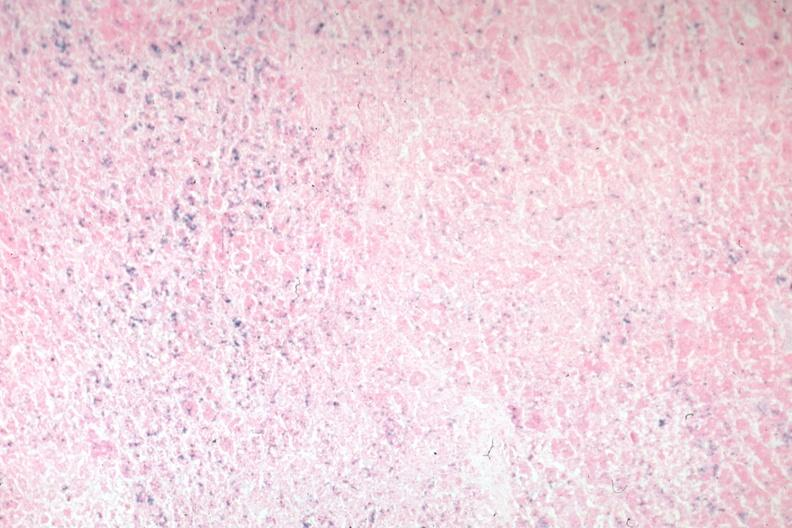what is present?
Answer the question using a single word or phrase. Endocrine 